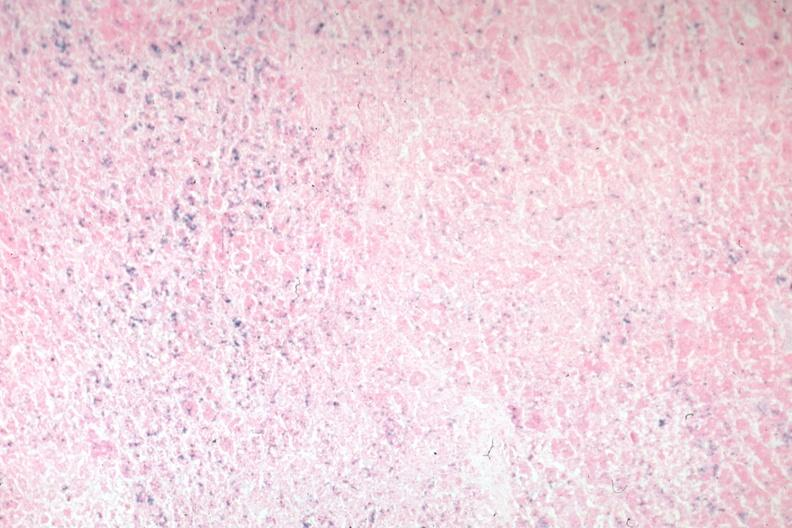what is present?
Answer the question using a single word or phrase. Endocrine 